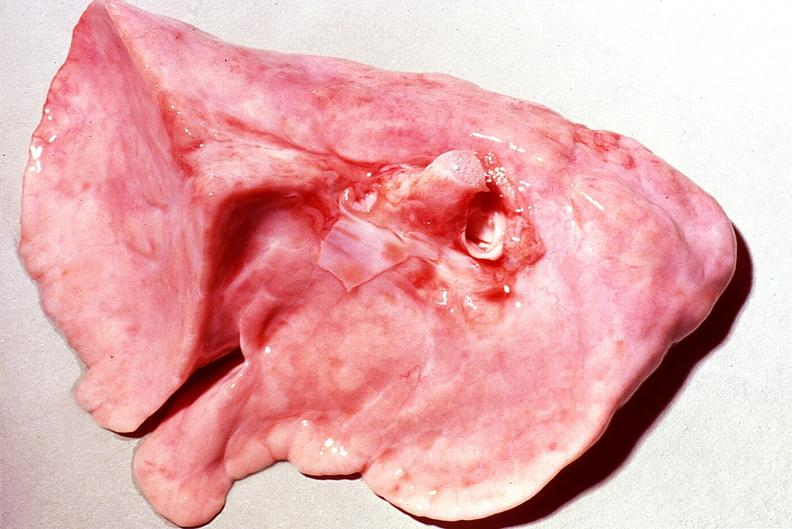what is present?
Answer the question using a single word or phrase. Respiratory 